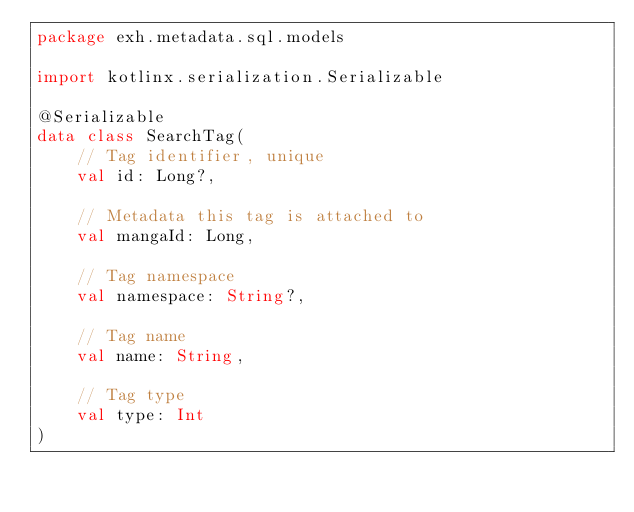<code> <loc_0><loc_0><loc_500><loc_500><_Kotlin_>package exh.metadata.sql.models

import kotlinx.serialization.Serializable

@Serializable
data class SearchTag(
    // Tag identifier, unique
    val id: Long?,

    // Metadata this tag is attached to
    val mangaId: Long,

    // Tag namespace
    val namespace: String?,

    // Tag name
    val name: String,

    // Tag type
    val type: Int
)
</code> 